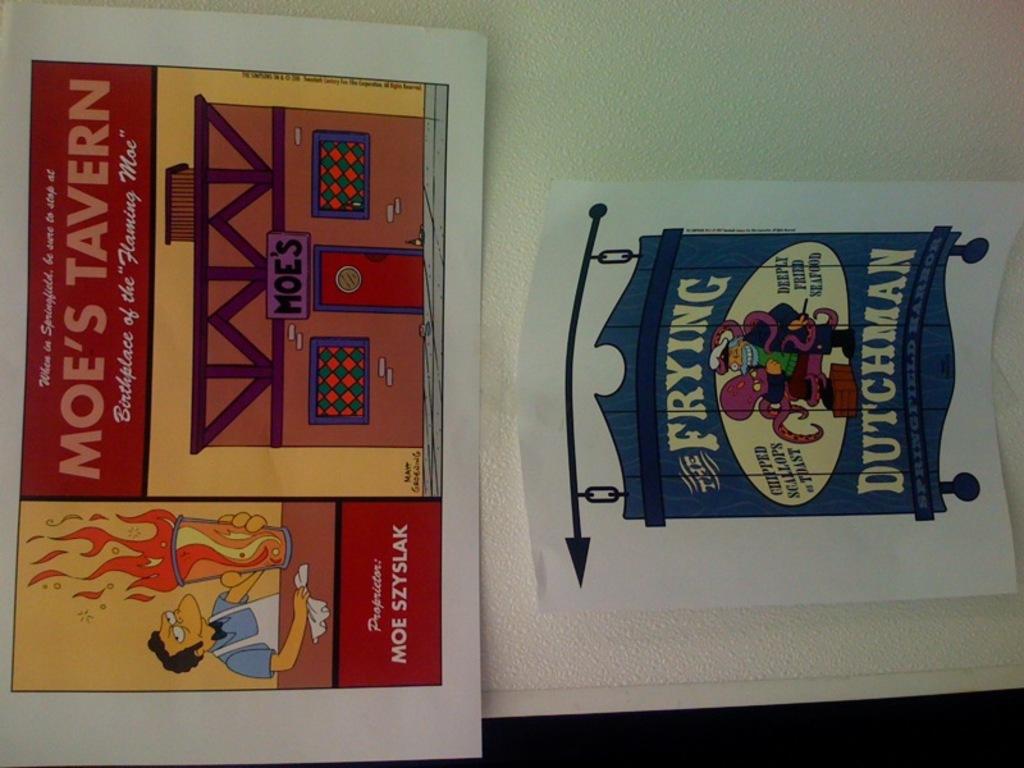How is the seafood described in the bottom advertisement?
Offer a terse response. Deeply fried. 